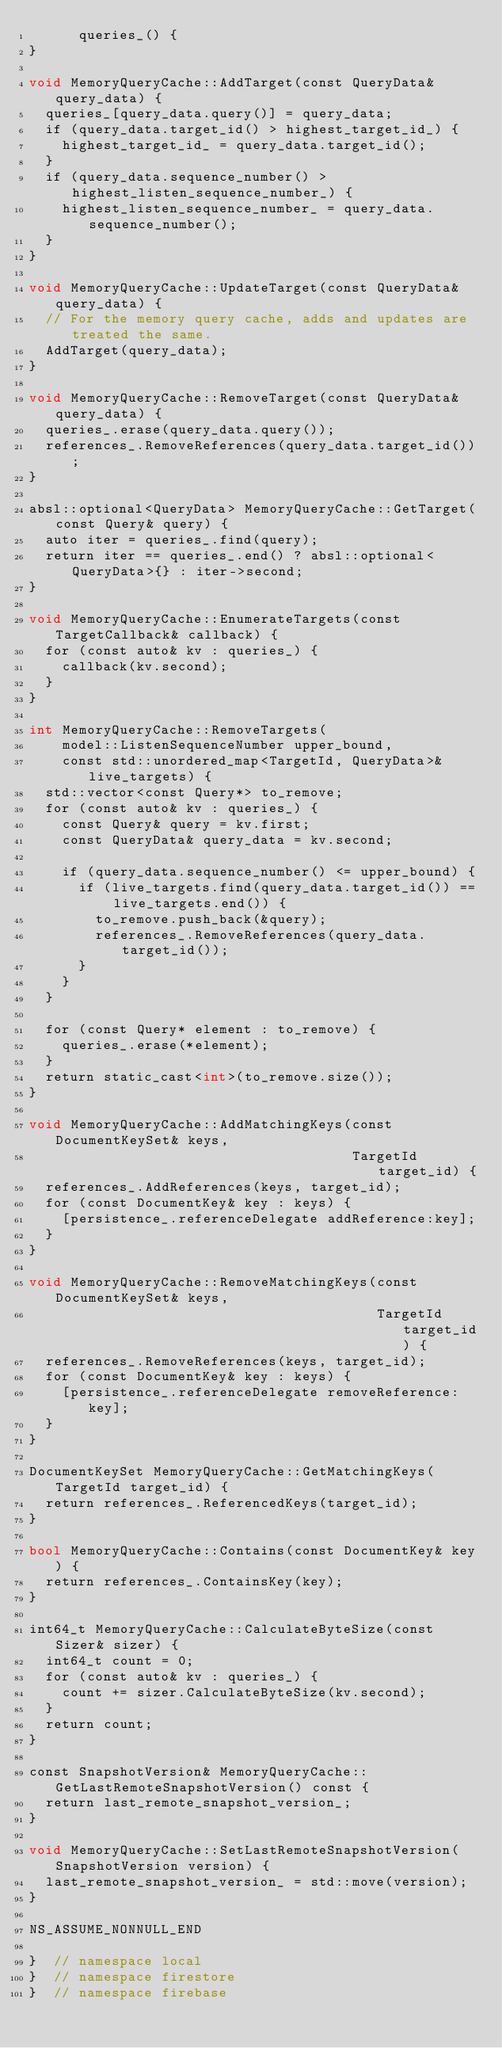<code> <loc_0><loc_0><loc_500><loc_500><_ObjectiveC_>      queries_() {
}

void MemoryQueryCache::AddTarget(const QueryData& query_data) {
  queries_[query_data.query()] = query_data;
  if (query_data.target_id() > highest_target_id_) {
    highest_target_id_ = query_data.target_id();
  }
  if (query_data.sequence_number() > highest_listen_sequence_number_) {
    highest_listen_sequence_number_ = query_data.sequence_number();
  }
}

void MemoryQueryCache::UpdateTarget(const QueryData& query_data) {
  // For the memory query cache, adds and updates are treated the same.
  AddTarget(query_data);
}

void MemoryQueryCache::RemoveTarget(const QueryData& query_data) {
  queries_.erase(query_data.query());
  references_.RemoveReferences(query_data.target_id());
}

absl::optional<QueryData> MemoryQueryCache::GetTarget(const Query& query) {
  auto iter = queries_.find(query);
  return iter == queries_.end() ? absl::optional<QueryData>{} : iter->second;
}

void MemoryQueryCache::EnumerateTargets(const TargetCallback& callback) {
  for (const auto& kv : queries_) {
    callback(kv.second);
  }
}

int MemoryQueryCache::RemoveTargets(
    model::ListenSequenceNumber upper_bound,
    const std::unordered_map<TargetId, QueryData>& live_targets) {
  std::vector<const Query*> to_remove;
  for (const auto& kv : queries_) {
    const Query& query = kv.first;
    const QueryData& query_data = kv.second;

    if (query_data.sequence_number() <= upper_bound) {
      if (live_targets.find(query_data.target_id()) == live_targets.end()) {
        to_remove.push_back(&query);
        references_.RemoveReferences(query_data.target_id());
      }
    }
  }

  for (const Query* element : to_remove) {
    queries_.erase(*element);
  }
  return static_cast<int>(to_remove.size());
}

void MemoryQueryCache::AddMatchingKeys(const DocumentKeySet& keys,
                                       TargetId target_id) {
  references_.AddReferences(keys, target_id);
  for (const DocumentKey& key : keys) {
    [persistence_.referenceDelegate addReference:key];
  }
}

void MemoryQueryCache::RemoveMatchingKeys(const DocumentKeySet& keys,
                                          TargetId target_id) {
  references_.RemoveReferences(keys, target_id);
  for (const DocumentKey& key : keys) {
    [persistence_.referenceDelegate removeReference:key];
  }
}

DocumentKeySet MemoryQueryCache::GetMatchingKeys(TargetId target_id) {
  return references_.ReferencedKeys(target_id);
}

bool MemoryQueryCache::Contains(const DocumentKey& key) {
  return references_.ContainsKey(key);
}

int64_t MemoryQueryCache::CalculateByteSize(const Sizer& sizer) {
  int64_t count = 0;
  for (const auto& kv : queries_) {
    count += sizer.CalculateByteSize(kv.second);
  }
  return count;
}

const SnapshotVersion& MemoryQueryCache::GetLastRemoteSnapshotVersion() const {
  return last_remote_snapshot_version_;
}

void MemoryQueryCache::SetLastRemoteSnapshotVersion(SnapshotVersion version) {
  last_remote_snapshot_version_ = std::move(version);
}

NS_ASSUME_NONNULL_END

}  // namespace local
}  // namespace firestore
}  // namespace firebase
</code> 